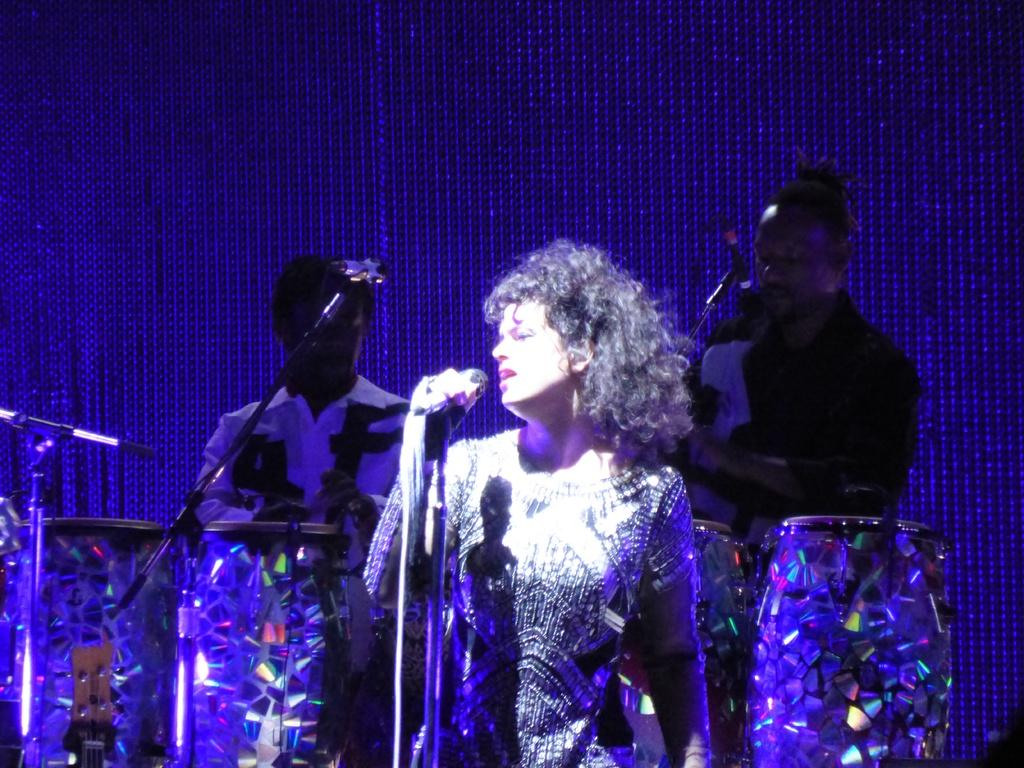What is the main subject of the image? The main subject of the subject of the image is a person standing in front of a mic. What are the other people in the image doing? There are two other people playing drums in the image. Can you describe the activity taking place in the image? The image depicts a musical performance, with one person singing into a mic and two others playing drums. What direction is the sea located in relation to the person standing in front of the mic? There is no sea present in the image, so it cannot be determined which direction it would be located in relation to the person. 